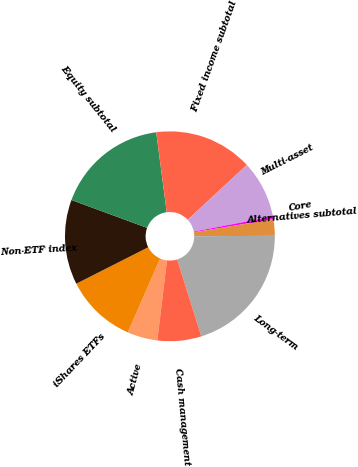<chart> <loc_0><loc_0><loc_500><loc_500><pie_chart><fcel>Active<fcel>iShares ETFs<fcel>Non-ETF index<fcel>Equity subtotal<fcel>Fixed income subtotal<fcel>Multi-asset<fcel>Core<fcel>Alternatives subtotal<fcel>Long-term<fcel>Cash management<nl><fcel>4.65%<fcel>10.97%<fcel>13.08%<fcel>17.3%<fcel>15.19%<fcel>8.86%<fcel>0.43%<fcel>2.54%<fcel>20.22%<fcel>6.76%<nl></chart> 